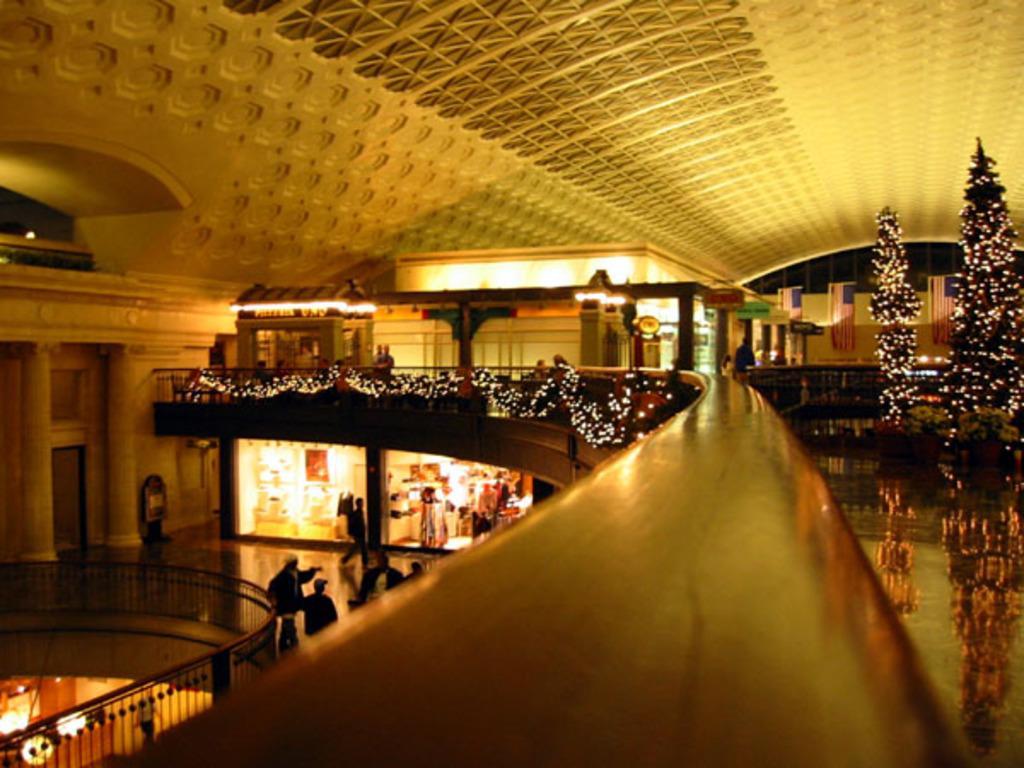In one or two sentences, can you explain what this image depicts? In this image on the right side there are trees. On the left side there are persons standing and walking, there are lights, there are railings and there are glasses, pillars and in the center on the top there are boards with some text written on it and there are lights. 